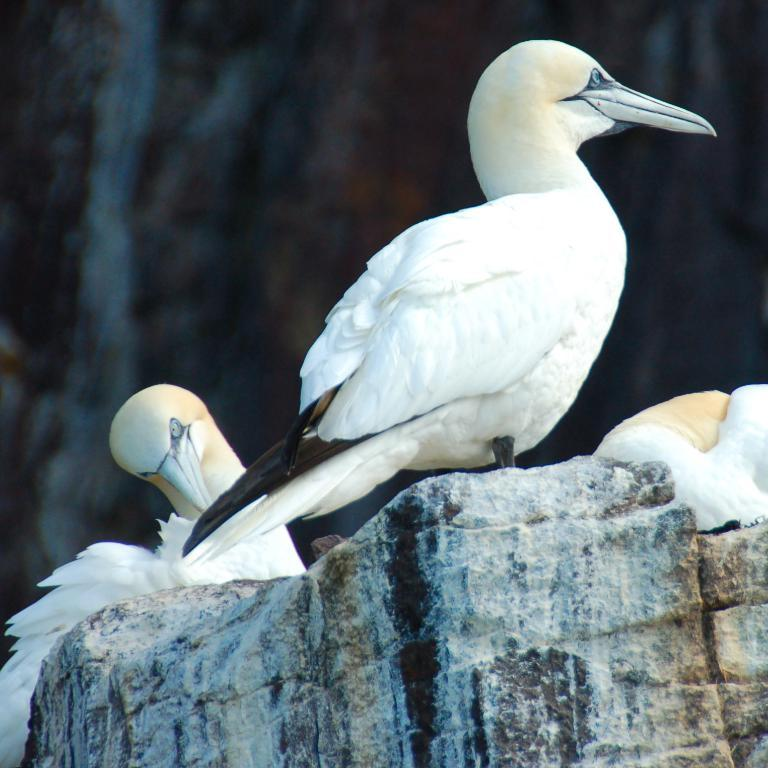What is located in the center of the image? There are birds in the center of the image. What can be seen at the bottom of the image? There is a rock at the bottom of the image. How does the boy burn the oranges in the image? There is no boy or oranges present in the image; it features birds and a rock. 